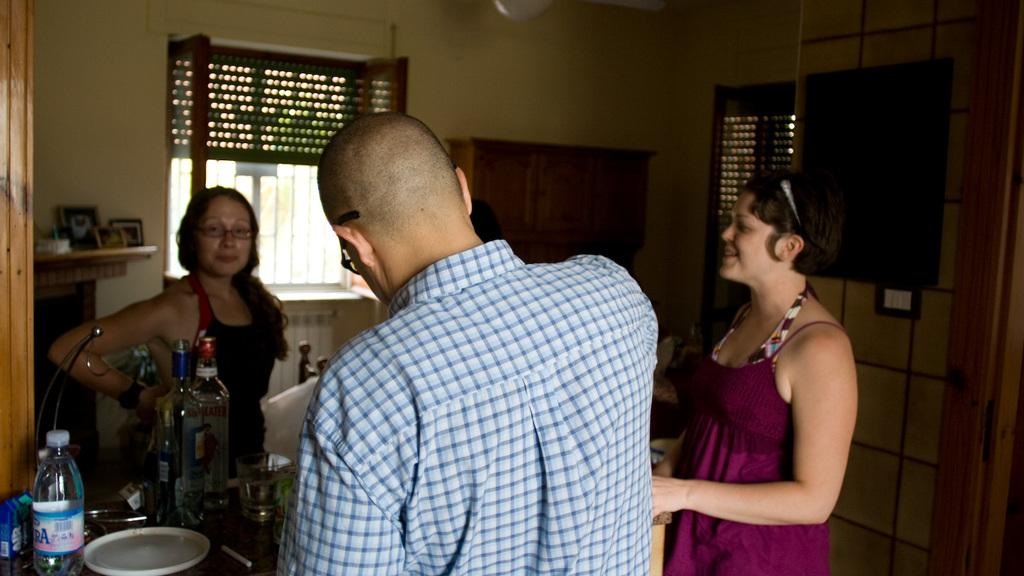How many people are in the image? There are persons standing in the image. What objects are on the table in the image? There are bottles, a plate, and glasses on the table. What can be seen in the background of the image? There is a wall, windows, and furniture in the background of the image. What type of wine is being served by the band in the image? There is no band or wine present in the image. 